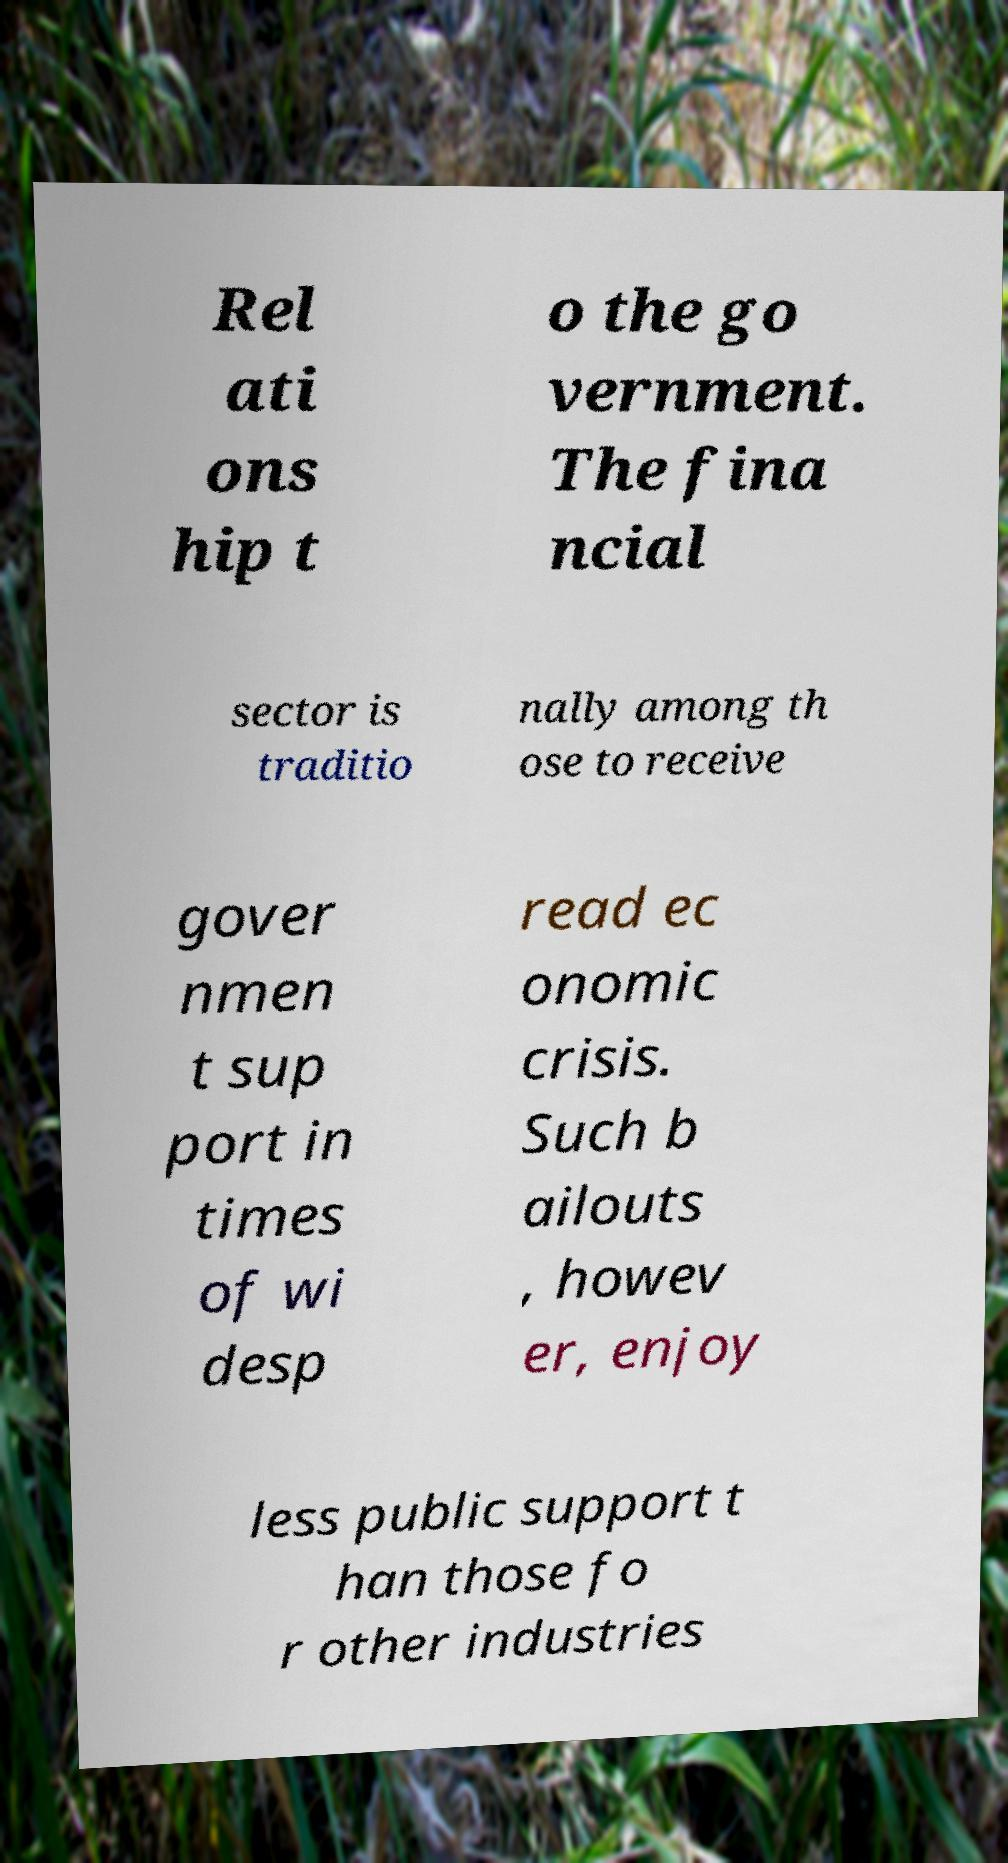Can you accurately transcribe the text from the provided image for me? Rel ati ons hip t o the go vernment. The fina ncial sector is traditio nally among th ose to receive gover nmen t sup port in times of wi desp read ec onomic crisis. Such b ailouts , howev er, enjoy less public support t han those fo r other industries 